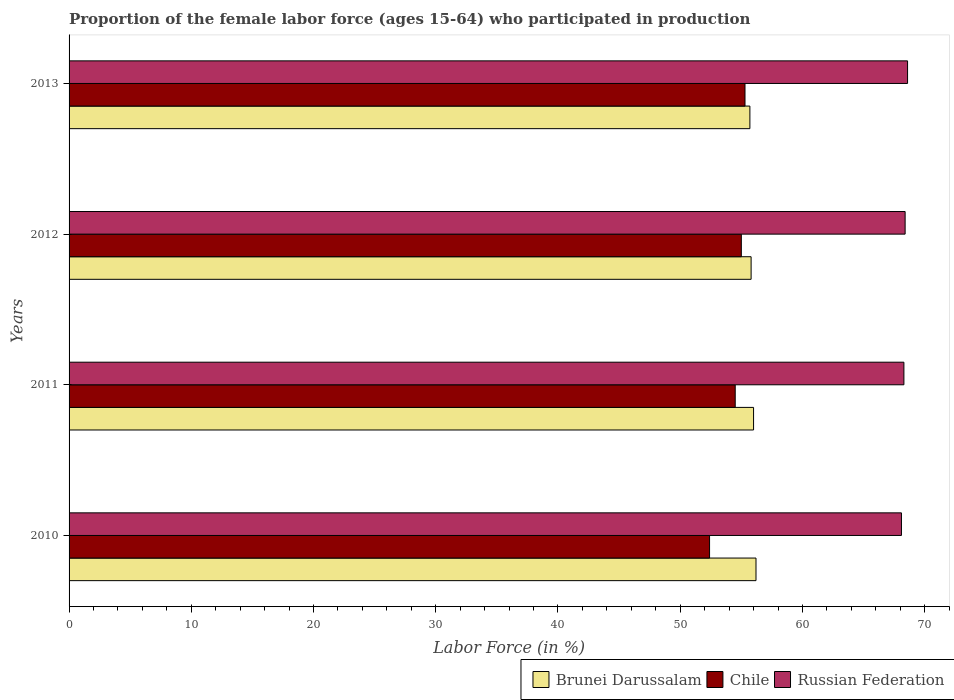Are the number of bars per tick equal to the number of legend labels?
Ensure brevity in your answer.  Yes. Are the number of bars on each tick of the Y-axis equal?
Keep it short and to the point. Yes. How many bars are there on the 3rd tick from the bottom?
Offer a very short reply. 3. In how many cases, is the number of bars for a given year not equal to the number of legend labels?
Your response must be concise. 0. What is the proportion of the female labor force who participated in production in Russian Federation in 2012?
Give a very brief answer. 68.4. Across all years, what is the maximum proportion of the female labor force who participated in production in Chile?
Offer a terse response. 55.3. Across all years, what is the minimum proportion of the female labor force who participated in production in Russian Federation?
Your answer should be compact. 68.1. In which year was the proportion of the female labor force who participated in production in Russian Federation minimum?
Your answer should be very brief. 2010. What is the total proportion of the female labor force who participated in production in Brunei Darussalam in the graph?
Offer a very short reply. 223.7. What is the difference between the proportion of the female labor force who participated in production in Russian Federation in 2010 and that in 2012?
Offer a very short reply. -0.3. What is the difference between the proportion of the female labor force who participated in production in Brunei Darussalam in 2010 and the proportion of the female labor force who participated in production in Russian Federation in 2013?
Your response must be concise. -12.4. What is the average proportion of the female labor force who participated in production in Chile per year?
Offer a terse response. 54.3. In the year 2012, what is the difference between the proportion of the female labor force who participated in production in Russian Federation and proportion of the female labor force who participated in production in Brunei Darussalam?
Your answer should be very brief. 12.6. In how many years, is the proportion of the female labor force who participated in production in Russian Federation greater than 64 %?
Provide a succinct answer. 4. What is the ratio of the proportion of the female labor force who participated in production in Chile in 2010 to that in 2011?
Ensure brevity in your answer.  0.96. Is the difference between the proportion of the female labor force who participated in production in Russian Federation in 2010 and 2013 greater than the difference between the proportion of the female labor force who participated in production in Brunei Darussalam in 2010 and 2013?
Provide a succinct answer. No. What is the difference between the highest and the second highest proportion of the female labor force who participated in production in Brunei Darussalam?
Provide a succinct answer. 0.2. What is the difference between the highest and the lowest proportion of the female labor force who participated in production in Russian Federation?
Ensure brevity in your answer.  0.5. What does the 1st bar from the top in 2011 represents?
Provide a succinct answer. Russian Federation. How many years are there in the graph?
Give a very brief answer. 4. Are the values on the major ticks of X-axis written in scientific E-notation?
Your answer should be compact. No. Does the graph contain any zero values?
Provide a short and direct response. No. Does the graph contain grids?
Your answer should be compact. No. What is the title of the graph?
Keep it short and to the point. Proportion of the female labor force (ages 15-64) who participated in production. Does "Equatorial Guinea" appear as one of the legend labels in the graph?
Your answer should be very brief. No. What is the Labor Force (in %) of Brunei Darussalam in 2010?
Offer a very short reply. 56.2. What is the Labor Force (in %) of Chile in 2010?
Provide a succinct answer. 52.4. What is the Labor Force (in %) in Russian Federation in 2010?
Provide a short and direct response. 68.1. What is the Labor Force (in %) of Brunei Darussalam in 2011?
Your response must be concise. 56. What is the Labor Force (in %) of Chile in 2011?
Give a very brief answer. 54.5. What is the Labor Force (in %) of Russian Federation in 2011?
Your response must be concise. 68.3. What is the Labor Force (in %) of Brunei Darussalam in 2012?
Keep it short and to the point. 55.8. What is the Labor Force (in %) of Russian Federation in 2012?
Provide a short and direct response. 68.4. What is the Labor Force (in %) of Brunei Darussalam in 2013?
Offer a terse response. 55.7. What is the Labor Force (in %) in Chile in 2013?
Offer a terse response. 55.3. What is the Labor Force (in %) in Russian Federation in 2013?
Give a very brief answer. 68.6. Across all years, what is the maximum Labor Force (in %) of Brunei Darussalam?
Your response must be concise. 56.2. Across all years, what is the maximum Labor Force (in %) of Chile?
Your response must be concise. 55.3. Across all years, what is the maximum Labor Force (in %) of Russian Federation?
Keep it short and to the point. 68.6. Across all years, what is the minimum Labor Force (in %) of Brunei Darussalam?
Give a very brief answer. 55.7. Across all years, what is the minimum Labor Force (in %) of Chile?
Give a very brief answer. 52.4. Across all years, what is the minimum Labor Force (in %) in Russian Federation?
Your answer should be very brief. 68.1. What is the total Labor Force (in %) of Brunei Darussalam in the graph?
Your answer should be very brief. 223.7. What is the total Labor Force (in %) in Chile in the graph?
Keep it short and to the point. 217.2. What is the total Labor Force (in %) in Russian Federation in the graph?
Offer a terse response. 273.4. What is the difference between the Labor Force (in %) of Brunei Darussalam in 2010 and that in 2011?
Offer a terse response. 0.2. What is the difference between the Labor Force (in %) of Chile in 2010 and that in 2011?
Ensure brevity in your answer.  -2.1. What is the difference between the Labor Force (in %) in Russian Federation in 2010 and that in 2011?
Offer a very short reply. -0.2. What is the difference between the Labor Force (in %) in Chile in 2010 and that in 2012?
Make the answer very short. -2.6. What is the difference between the Labor Force (in %) in Russian Federation in 2010 and that in 2012?
Offer a very short reply. -0.3. What is the difference between the Labor Force (in %) of Chile in 2010 and that in 2013?
Ensure brevity in your answer.  -2.9. What is the difference between the Labor Force (in %) in Brunei Darussalam in 2011 and that in 2012?
Ensure brevity in your answer.  0.2. What is the difference between the Labor Force (in %) of Russian Federation in 2011 and that in 2012?
Ensure brevity in your answer.  -0.1. What is the difference between the Labor Force (in %) of Chile in 2012 and that in 2013?
Your response must be concise. -0.3. What is the difference between the Labor Force (in %) in Russian Federation in 2012 and that in 2013?
Your response must be concise. -0.2. What is the difference between the Labor Force (in %) in Chile in 2010 and the Labor Force (in %) in Russian Federation in 2011?
Ensure brevity in your answer.  -15.9. What is the difference between the Labor Force (in %) of Brunei Darussalam in 2010 and the Labor Force (in %) of Russian Federation in 2012?
Your answer should be very brief. -12.2. What is the difference between the Labor Force (in %) in Brunei Darussalam in 2010 and the Labor Force (in %) in Chile in 2013?
Keep it short and to the point. 0.9. What is the difference between the Labor Force (in %) in Chile in 2010 and the Labor Force (in %) in Russian Federation in 2013?
Provide a short and direct response. -16.2. What is the difference between the Labor Force (in %) in Brunei Darussalam in 2011 and the Labor Force (in %) in Russian Federation in 2012?
Give a very brief answer. -12.4. What is the difference between the Labor Force (in %) in Brunei Darussalam in 2011 and the Labor Force (in %) in Chile in 2013?
Your answer should be very brief. 0.7. What is the difference between the Labor Force (in %) in Chile in 2011 and the Labor Force (in %) in Russian Federation in 2013?
Offer a terse response. -14.1. What is the difference between the Labor Force (in %) of Brunei Darussalam in 2012 and the Labor Force (in %) of Russian Federation in 2013?
Your answer should be compact. -12.8. What is the difference between the Labor Force (in %) of Chile in 2012 and the Labor Force (in %) of Russian Federation in 2013?
Provide a short and direct response. -13.6. What is the average Labor Force (in %) of Brunei Darussalam per year?
Keep it short and to the point. 55.92. What is the average Labor Force (in %) of Chile per year?
Give a very brief answer. 54.3. What is the average Labor Force (in %) in Russian Federation per year?
Make the answer very short. 68.35. In the year 2010, what is the difference between the Labor Force (in %) of Brunei Darussalam and Labor Force (in %) of Russian Federation?
Your answer should be very brief. -11.9. In the year 2010, what is the difference between the Labor Force (in %) in Chile and Labor Force (in %) in Russian Federation?
Your answer should be very brief. -15.7. In the year 2011, what is the difference between the Labor Force (in %) of Brunei Darussalam and Labor Force (in %) of Chile?
Your response must be concise. 1.5. In the year 2011, what is the difference between the Labor Force (in %) in Brunei Darussalam and Labor Force (in %) in Russian Federation?
Provide a succinct answer. -12.3. In the year 2013, what is the difference between the Labor Force (in %) in Chile and Labor Force (in %) in Russian Federation?
Offer a very short reply. -13.3. What is the ratio of the Labor Force (in %) of Brunei Darussalam in 2010 to that in 2011?
Your response must be concise. 1. What is the ratio of the Labor Force (in %) in Chile in 2010 to that in 2011?
Ensure brevity in your answer.  0.96. What is the ratio of the Labor Force (in %) in Russian Federation in 2010 to that in 2011?
Provide a short and direct response. 1. What is the ratio of the Labor Force (in %) of Brunei Darussalam in 2010 to that in 2012?
Your answer should be very brief. 1.01. What is the ratio of the Labor Force (in %) of Chile in 2010 to that in 2012?
Keep it short and to the point. 0.95. What is the ratio of the Labor Force (in %) in Russian Federation in 2010 to that in 2012?
Your answer should be very brief. 1. What is the ratio of the Labor Force (in %) of Chile in 2010 to that in 2013?
Your response must be concise. 0.95. What is the ratio of the Labor Force (in %) of Brunei Darussalam in 2011 to that in 2012?
Your answer should be compact. 1. What is the ratio of the Labor Force (in %) of Chile in 2011 to that in 2012?
Ensure brevity in your answer.  0.99. What is the ratio of the Labor Force (in %) in Brunei Darussalam in 2011 to that in 2013?
Provide a short and direct response. 1.01. What is the ratio of the Labor Force (in %) of Chile in 2011 to that in 2013?
Your answer should be very brief. 0.99. What is the ratio of the Labor Force (in %) in Russian Federation in 2011 to that in 2013?
Make the answer very short. 1. What is the ratio of the Labor Force (in %) of Chile in 2012 to that in 2013?
Ensure brevity in your answer.  0.99. What is the ratio of the Labor Force (in %) of Russian Federation in 2012 to that in 2013?
Make the answer very short. 1. What is the difference between the highest and the lowest Labor Force (in %) of Brunei Darussalam?
Offer a very short reply. 0.5. What is the difference between the highest and the lowest Labor Force (in %) of Russian Federation?
Provide a short and direct response. 0.5. 